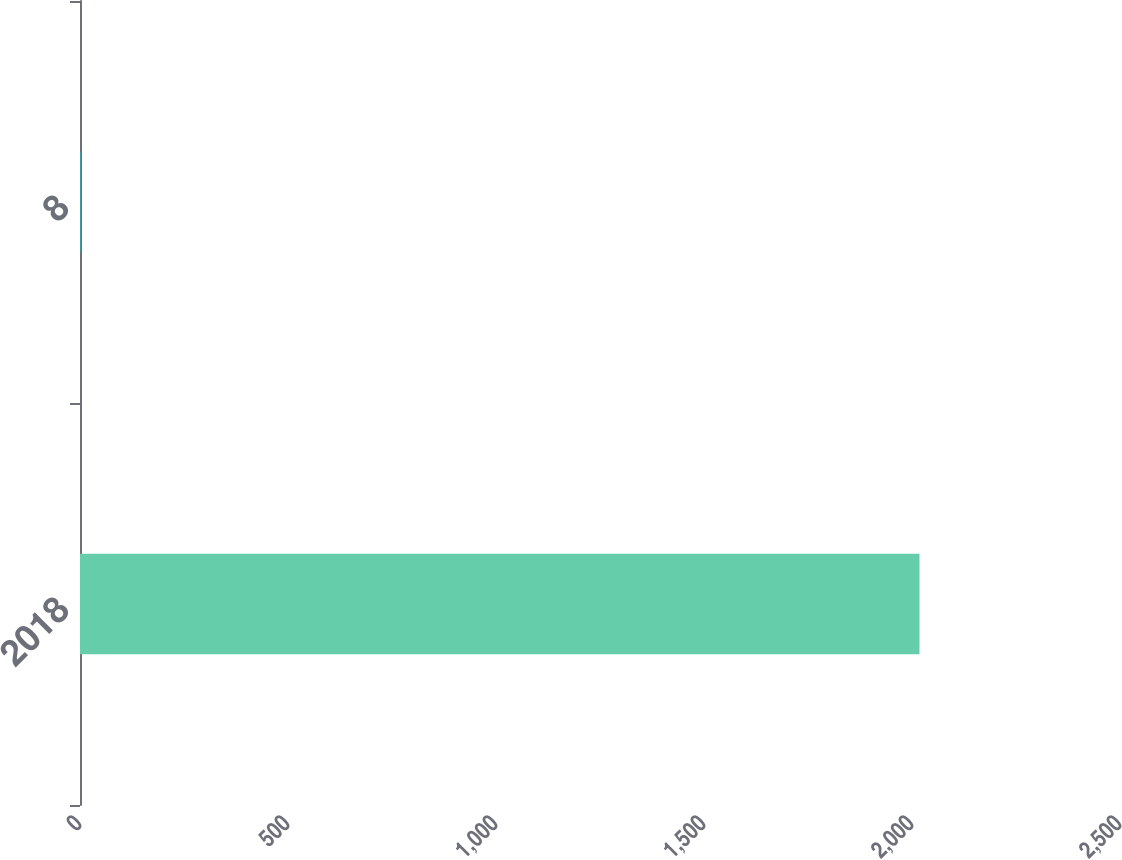Convert chart. <chart><loc_0><loc_0><loc_500><loc_500><bar_chart><fcel>2018<fcel>8<nl><fcel>2018<fcel>1<nl></chart> 